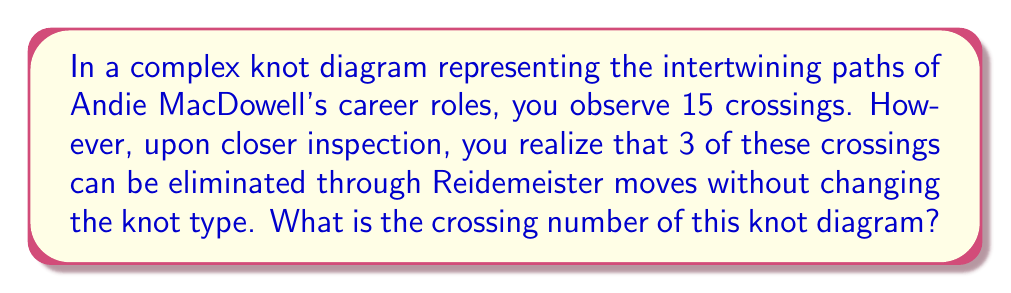Give your solution to this math problem. To determine the crossing number of this complex knot diagram, we need to follow these steps:

1. Identify the initial number of crossings:
   Initially, we observe 15 crossings in the knot diagram.

2. Recognize the reducible crossings:
   We're told that 3 of these crossings can be eliminated through Reidemeister moves without changing the knot type.

3. Calculate the minimum number of crossings:
   The crossing number is defined as the minimum number of crossings in any diagram of the knot. To find this, we subtract the number of reducible crossings from the total crossings:

   $$\text{Crossing Number} = \text{Total Crossings} - \text{Reducible Crossings}$$
   $$\text{Crossing Number} = 15 - 3 = 12$$

4. Verify the result:
   The crossing number of 12 represents the minimum number of crossings needed to represent this particular knot, symbolizing the essential intersections in Andie MacDowell's career path that cannot be simplified further.
Answer: 12 